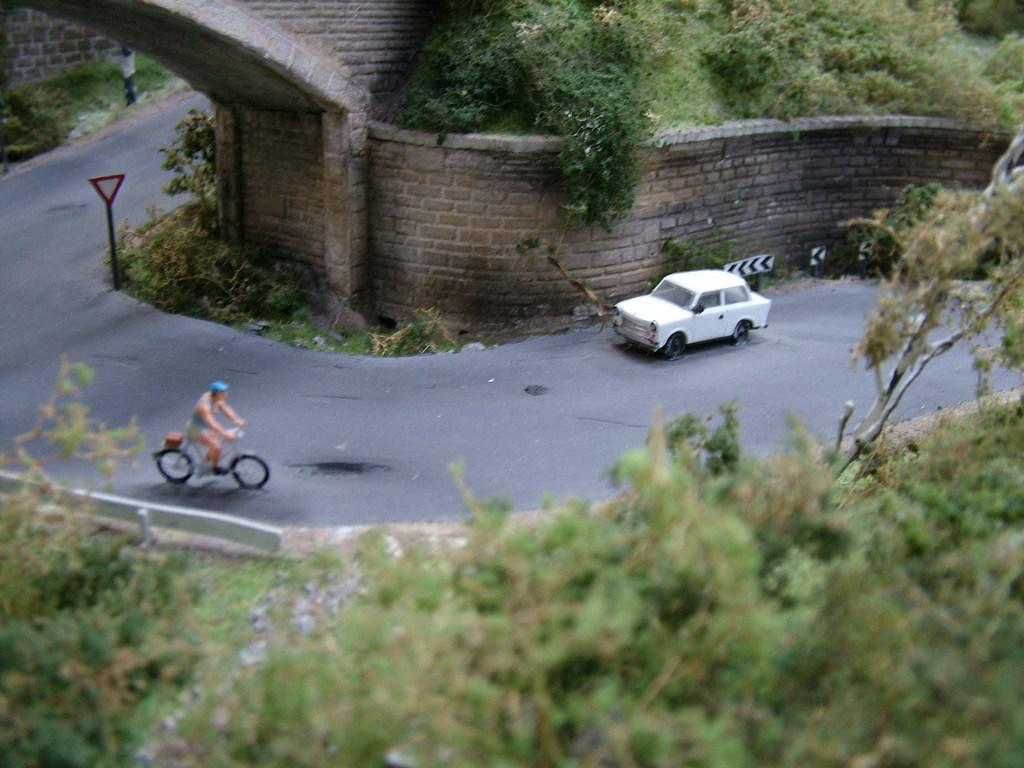What type of vehicle is on the road in the image? There is a car on the road in the image. What is the person in the image doing? The person is riding a bicycle. What can be seen on the side of the road? There is a signboard in the image. What type of natural elements are present in the image? Trees and plants are visible in the image. What type of pan is being used to cook food in the image? There is no pan or cooking activity present in the image. What event is taking place in the image? There is no specific event depicted in the image; it shows a car, a person riding a bicycle, a signboard, trees, and plants. 